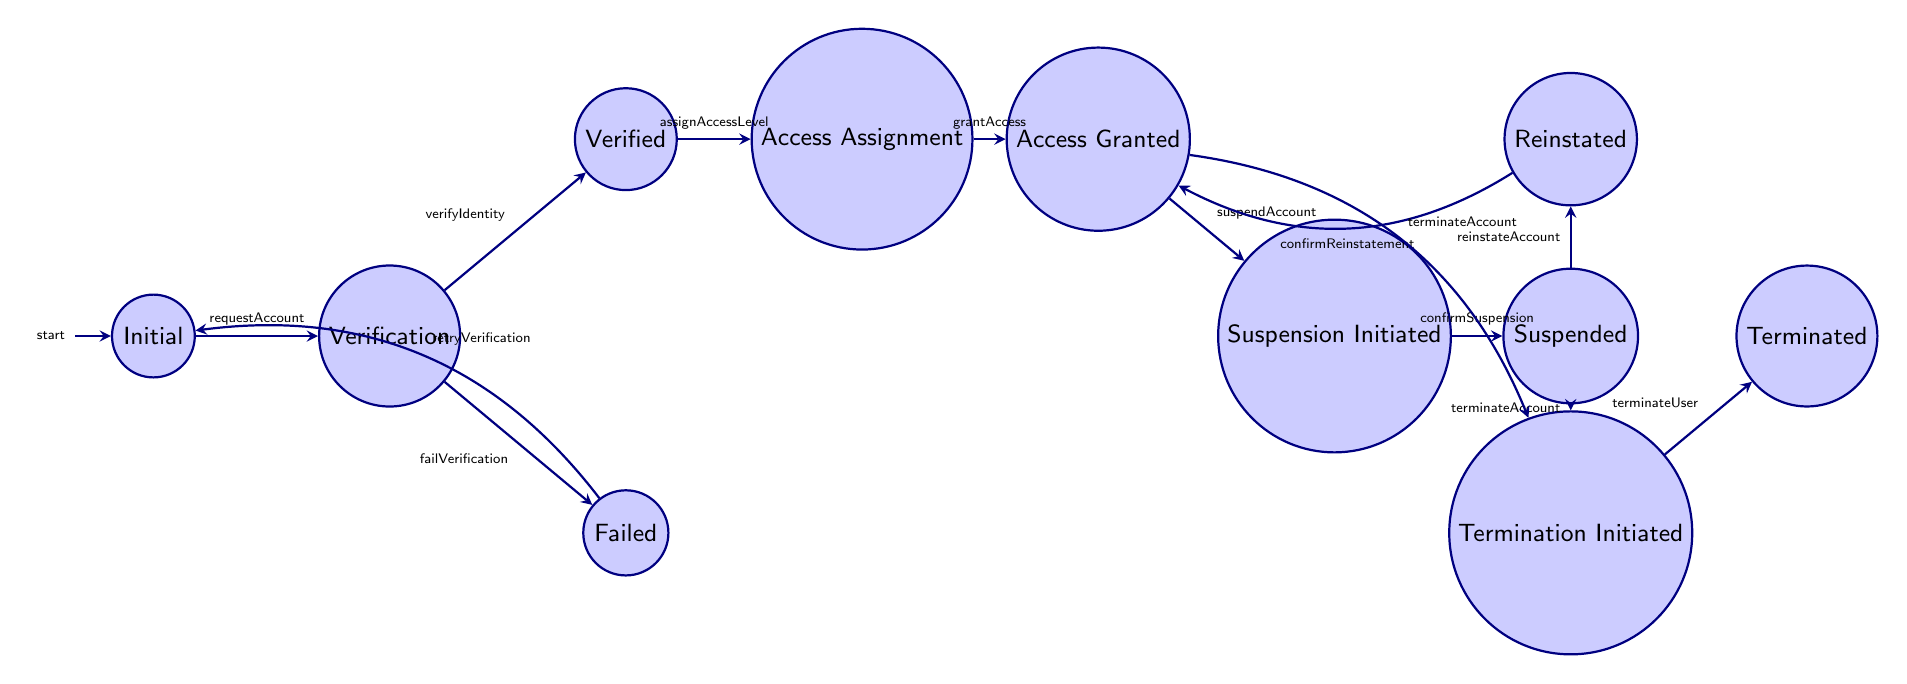What is the starting state in the account access management process? The initial state is represented by the node "Account Request Initiated," which is the first step in the process.
Answer: Account Request Initiated How many transitions are there from the "Identity Verification Pending" state? From the "Identity Verification Pending" state, there are two possible transitions: "Identity Verified" and "Identity Verification Failed." Thus, there are two transitions.
Answer: 2 What state follows after "User Access Granted" if the account gets suspended? The state that follows "User Access Granted" after triggering the event "suspendAccount" is "Account Suspension Initiated."
Answer: Account Suspension Initiated If the identity verification fails, where does the process return? When the identity verification fails, the process transitions back to the "Account Request Initiated" state, allowing for a retry.
Answer: Account Request Initiated What is the final state of user access management after termination? The final state after completing the process of terminating a user account is "User Access Terminated."
Answer: User Access Terminated How many states are there in total in this finite state machine diagram? The diagram contains a total of 11 states, each representing a step in the user account access management process.
Answer: 11 What is the transition event from "User Access Suspended" to "Account Termination Initiated"? The transition event that occurs from "User Access Suspended" to "Account Termination Initiated" is triggered by the event "terminateAccount."
Answer: terminateAccount What happens after the "User Access Reinstated" state? After the "User Access Reinstated" state, the process transitions back to "User Access Granted" upon confirming the reinstatement.
Answer: User Access Granted 